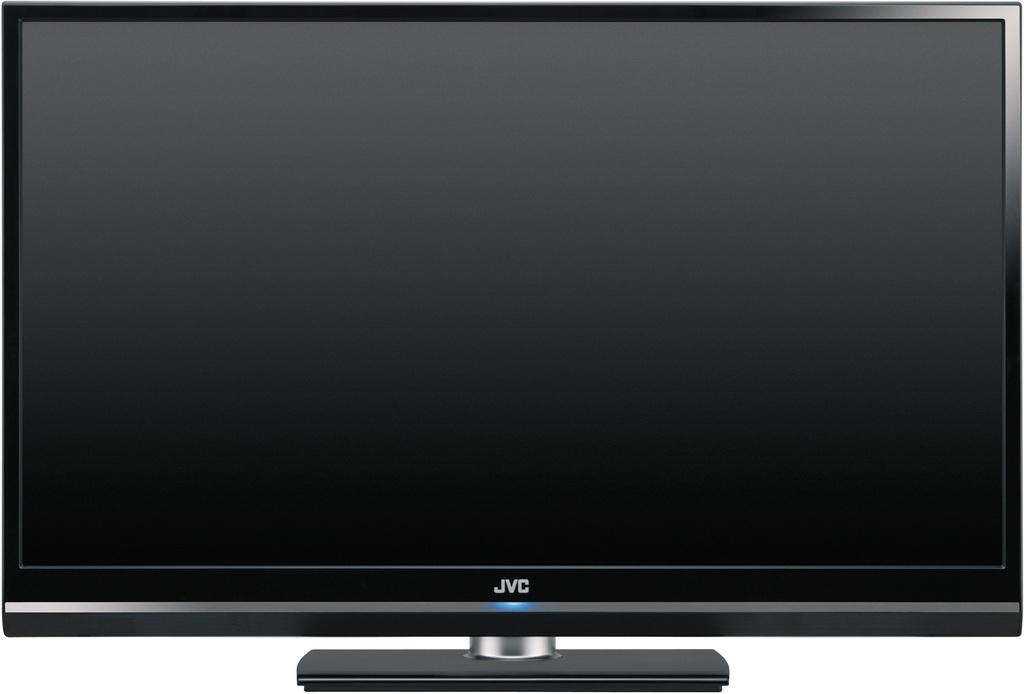<image>
Present a compact description of the photo's key features. A large black JVC brand name tv on a small pedestal. 